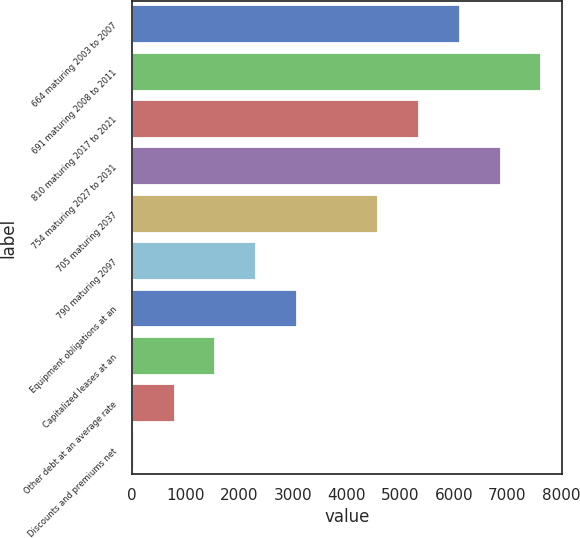<chart> <loc_0><loc_0><loc_500><loc_500><bar_chart><fcel>664 maturing 2003 to 2007<fcel>691 maturing 2008 to 2011<fcel>810 maturing 2017 to 2021<fcel>754 maturing 2027 to 2031<fcel>705 maturing 2037<fcel>790 maturing 2097<fcel>Equipment obligations at an<fcel>Capitalized leases at an<fcel>Other debt at an average rate<fcel>Discounts and premiums net<nl><fcel>6112<fcel>7632<fcel>5352<fcel>6872<fcel>4592<fcel>2312<fcel>3072<fcel>1552<fcel>792<fcel>32<nl></chart> 